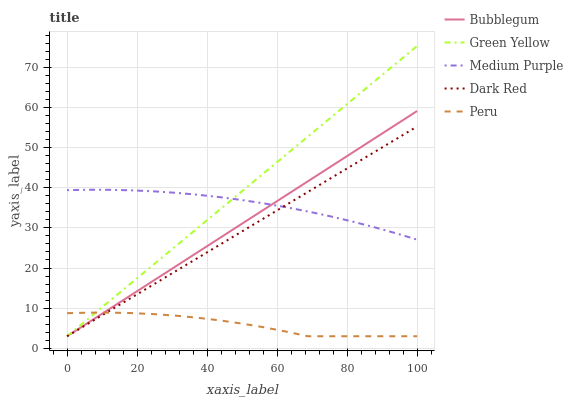Does Peru have the minimum area under the curve?
Answer yes or no. Yes. Does Green Yellow have the maximum area under the curve?
Answer yes or no. Yes. Does Dark Red have the minimum area under the curve?
Answer yes or no. No. Does Dark Red have the maximum area under the curve?
Answer yes or no. No. Is Dark Red the smoothest?
Answer yes or no. Yes. Is Peru the roughest?
Answer yes or no. Yes. Is Green Yellow the smoothest?
Answer yes or no. No. Is Green Yellow the roughest?
Answer yes or no. No. Does Dark Red have the lowest value?
Answer yes or no. Yes. Does Green Yellow have the highest value?
Answer yes or no. Yes. Does Dark Red have the highest value?
Answer yes or no. No. Is Peru less than Medium Purple?
Answer yes or no. Yes. Is Medium Purple greater than Peru?
Answer yes or no. Yes. Does Bubblegum intersect Medium Purple?
Answer yes or no. Yes. Is Bubblegum less than Medium Purple?
Answer yes or no. No. Is Bubblegum greater than Medium Purple?
Answer yes or no. No. Does Peru intersect Medium Purple?
Answer yes or no. No. 